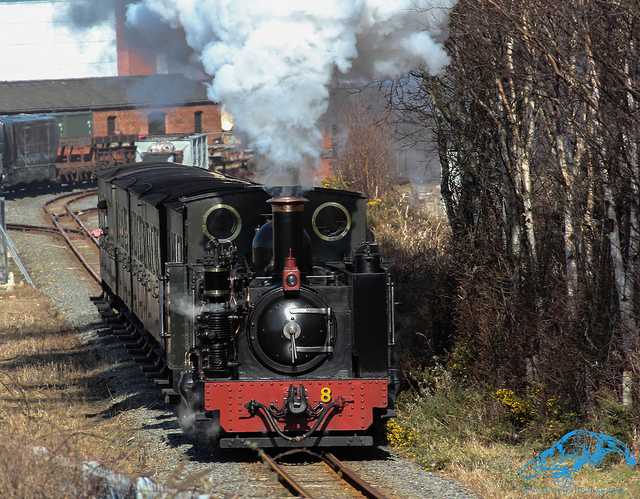Read and extract the text from this image. 8 